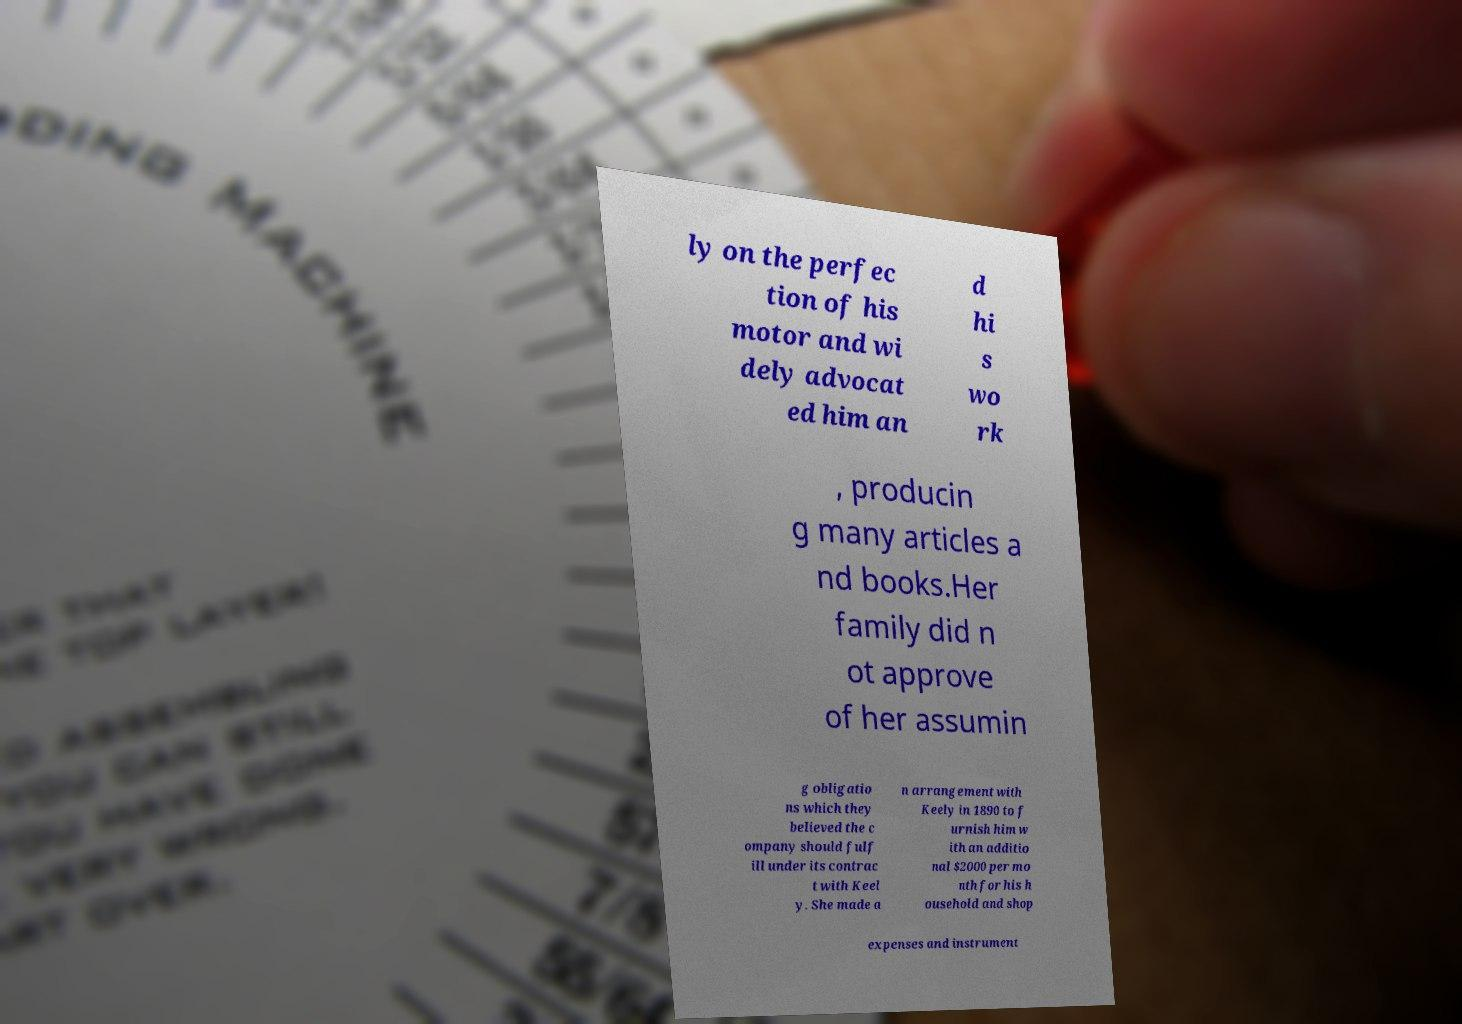What messages or text are displayed in this image? I need them in a readable, typed format. ly on the perfec tion of his motor and wi dely advocat ed him an d hi s wo rk , producin g many articles a nd books.Her family did n ot approve of her assumin g obligatio ns which they believed the c ompany should fulf ill under its contrac t with Keel y. She made a n arrangement with Keely in 1890 to f urnish him w ith an additio nal $2000 per mo nth for his h ousehold and shop expenses and instrument 